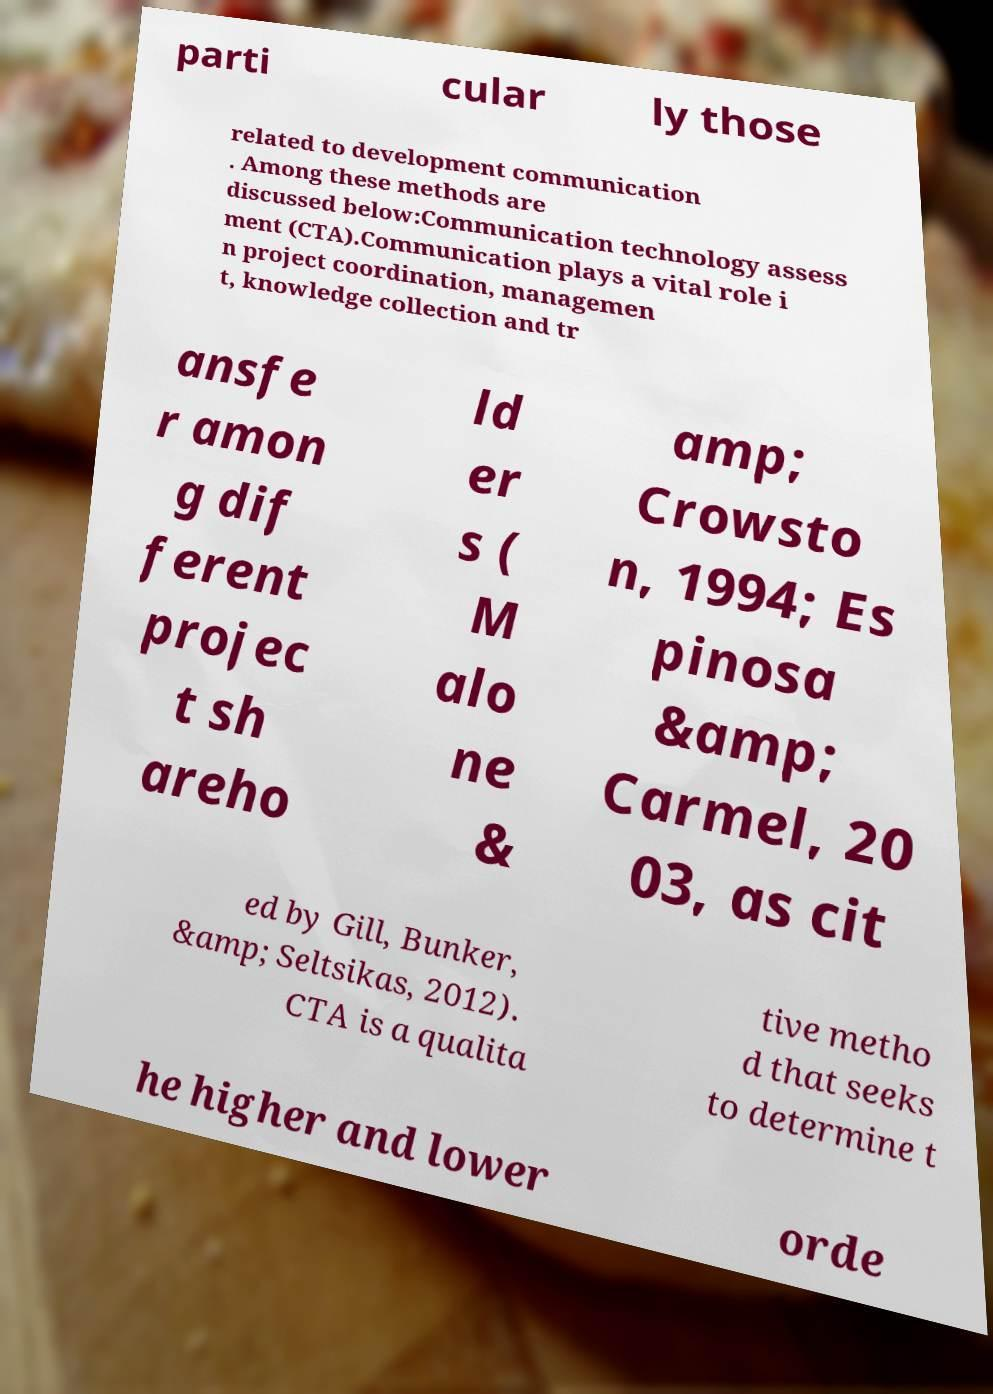What messages or text are displayed in this image? I need them in a readable, typed format. parti cular ly those related to development communication . Among these methods are discussed below:Communication technology assess ment (CTA).Communication plays a vital role i n project coordination, managemen t, knowledge collection and tr ansfe r amon g dif ferent projec t sh areho ld er s ( M alo ne & amp; Crowsto n, 1994; Es pinosa &amp; Carmel, 20 03, as cit ed by Gill, Bunker, &amp; Seltsikas, 2012). CTA is a qualita tive metho d that seeks to determine t he higher and lower orde 